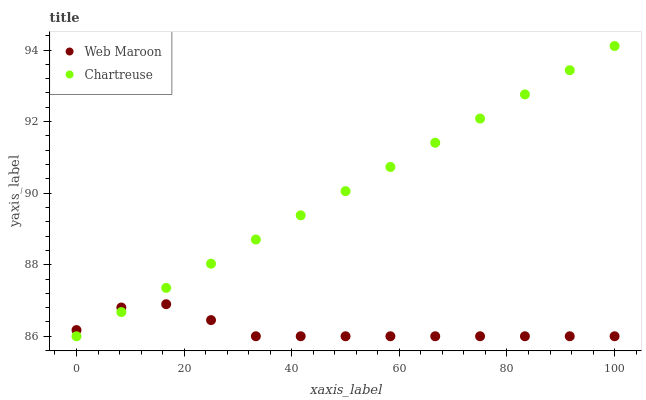Does Web Maroon have the minimum area under the curve?
Answer yes or no. Yes. Does Chartreuse have the maximum area under the curve?
Answer yes or no. Yes. Does Web Maroon have the maximum area under the curve?
Answer yes or no. No. Is Chartreuse the smoothest?
Answer yes or no. Yes. Is Web Maroon the roughest?
Answer yes or no. Yes. Is Web Maroon the smoothest?
Answer yes or no. No. Does Chartreuse have the lowest value?
Answer yes or no. Yes. Does Chartreuse have the highest value?
Answer yes or no. Yes. Does Web Maroon have the highest value?
Answer yes or no. No. Does Web Maroon intersect Chartreuse?
Answer yes or no. Yes. Is Web Maroon less than Chartreuse?
Answer yes or no. No. Is Web Maroon greater than Chartreuse?
Answer yes or no. No. 